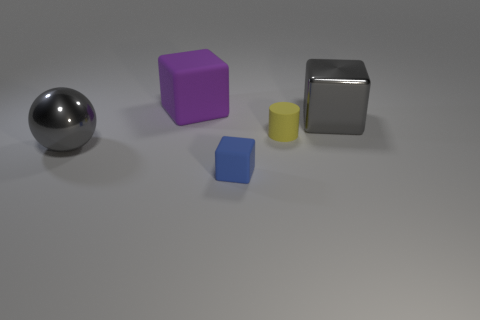Add 4 purple blocks. How many objects exist? 9 Subtract all cubes. How many objects are left? 2 Subtract all large purple cubes. Subtract all small yellow things. How many objects are left? 3 Add 5 big gray blocks. How many big gray blocks are left? 6 Add 5 small blocks. How many small blocks exist? 6 Subtract 1 blue cubes. How many objects are left? 4 